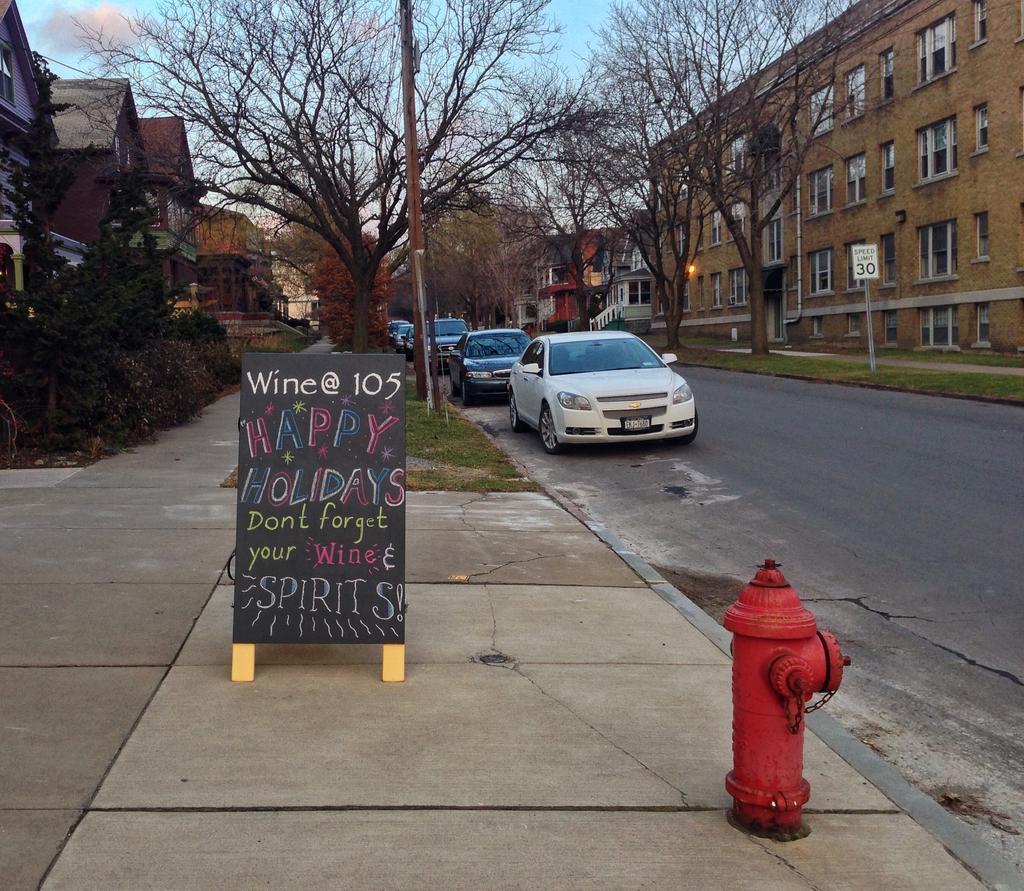In one or two sentences, can you explain what this image depicts? In this image I can see the road. To the side of the road I can see the fire hydrant and the boards. I can also see many trees and the buildings with windows. In the background I can see the sky. 